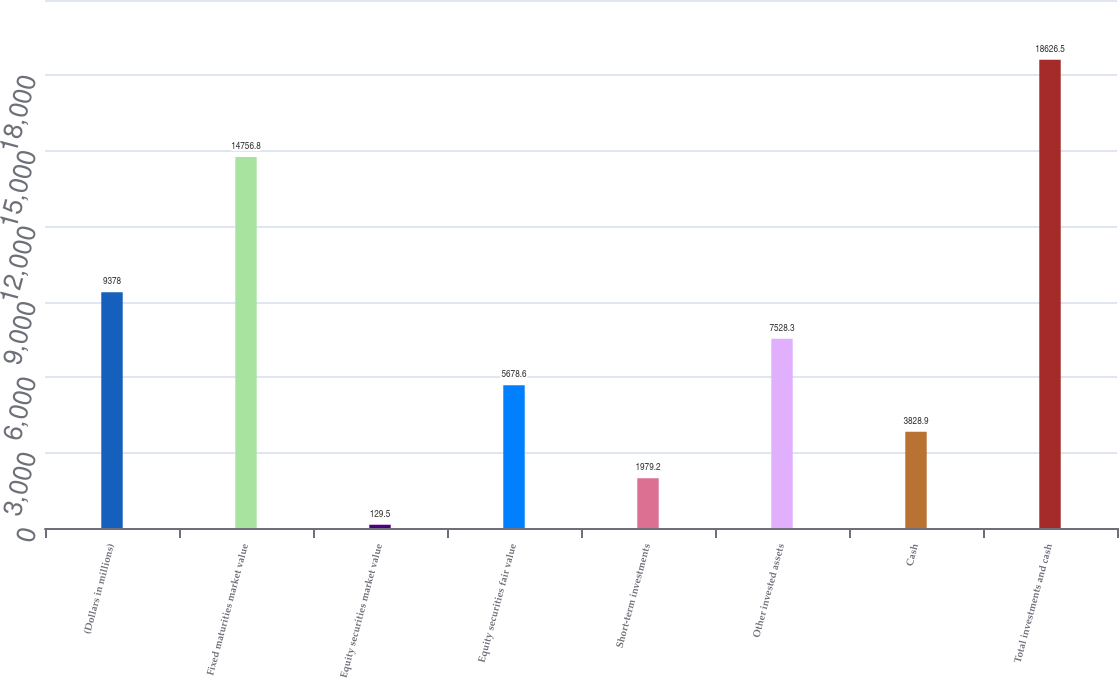Convert chart. <chart><loc_0><loc_0><loc_500><loc_500><bar_chart><fcel>(Dollars in millions)<fcel>Fixed maturities market value<fcel>Equity securities market value<fcel>Equity securities fair value<fcel>Short-term investments<fcel>Other invested assets<fcel>Cash<fcel>Total investments and cash<nl><fcel>9378<fcel>14756.8<fcel>129.5<fcel>5678.6<fcel>1979.2<fcel>7528.3<fcel>3828.9<fcel>18626.5<nl></chart> 